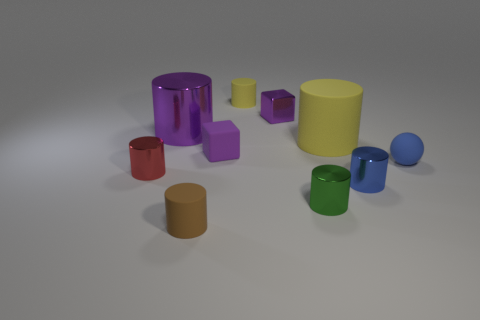Subtract all tiny brown rubber cylinders. How many cylinders are left? 6 Subtract all red cylinders. How many cylinders are left? 6 Subtract all blocks. How many objects are left? 8 Subtract all large shiny things. Subtract all large matte cylinders. How many objects are left? 8 Add 2 small red metal objects. How many small red metal objects are left? 3 Add 6 tiny gray metal balls. How many tiny gray metal balls exist? 6 Subtract 1 brown cylinders. How many objects are left? 9 Subtract 5 cylinders. How many cylinders are left? 2 Subtract all yellow spheres. Subtract all purple blocks. How many spheres are left? 1 Subtract all purple balls. How many green cylinders are left? 1 